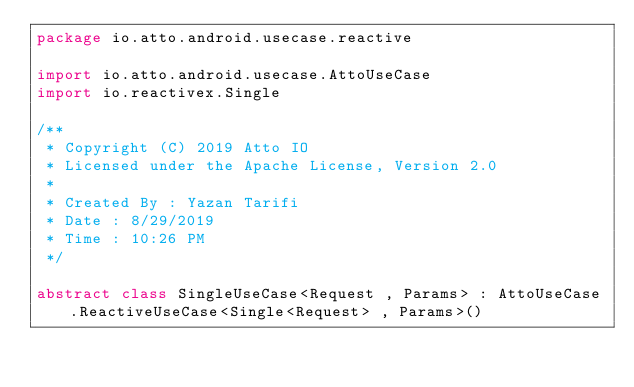<code> <loc_0><loc_0><loc_500><loc_500><_Kotlin_>package io.atto.android.usecase.reactive

import io.atto.android.usecase.AttoUseCase
import io.reactivex.Single

/**
 * Copyright (C) 2019 Atto IO
 * Licensed under the Apache License, Version 2.0
 *
 * Created By : Yazan Tarifi
 * Date : 8/29/2019
 * Time : 10:26 PM
 */

abstract class SingleUseCase<Request , Params> : AttoUseCase.ReactiveUseCase<Single<Request> , Params>()
</code> 